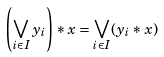Convert formula to latex. <formula><loc_0><loc_0><loc_500><loc_500>\left ( \bigvee _ { i \in I } { y _ { i } } \right ) * { x } = \bigvee _ { i \in I } ( y _ { i } * x )</formula> 